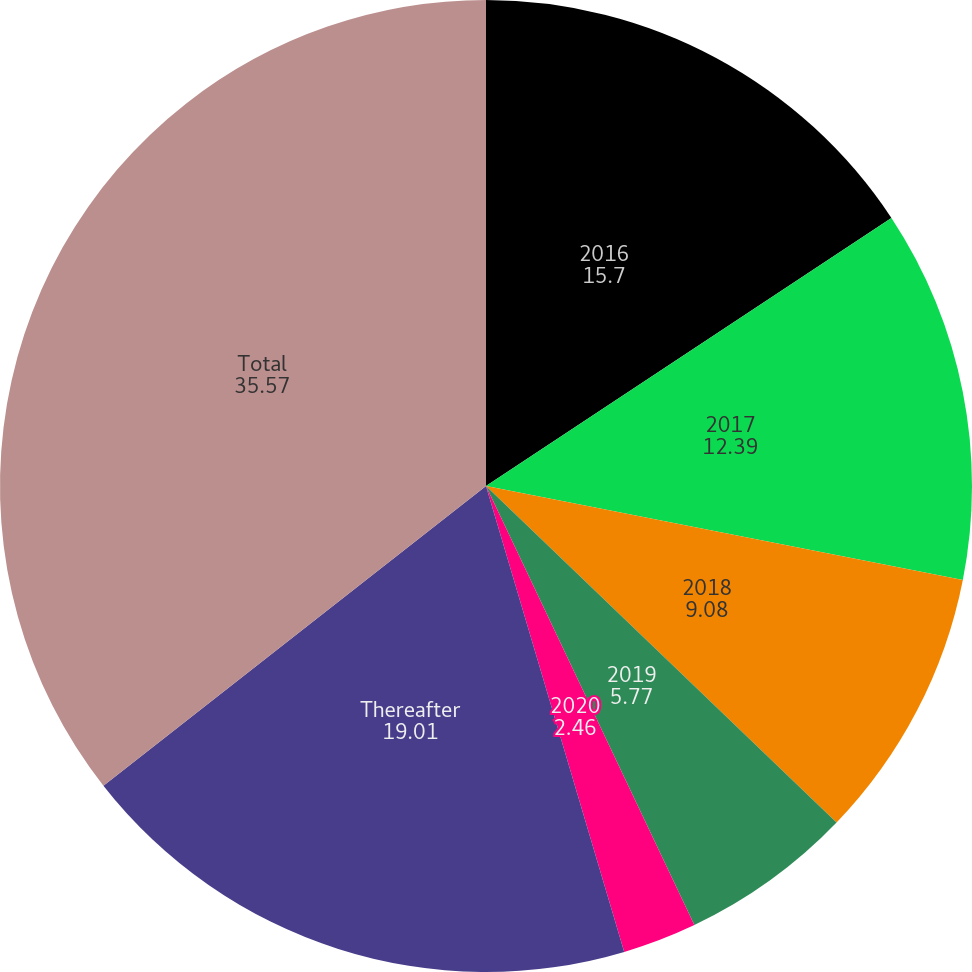<chart> <loc_0><loc_0><loc_500><loc_500><pie_chart><fcel>2016<fcel>2017<fcel>2018<fcel>2019<fcel>2020<fcel>Thereafter<fcel>Total<nl><fcel>15.7%<fcel>12.39%<fcel>9.08%<fcel>5.77%<fcel>2.46%<fcel>19.01%<fcel>35.57%<nl></chart> 